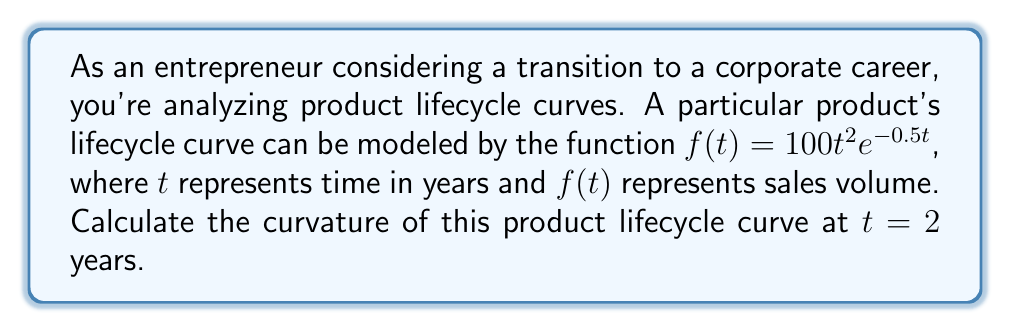Teach me how to tackle this problem. To calculate the curvature of the product lifecycle curve, we'll follow these steps:

1) The formula for curvature $\kappa$ of a function $y = f(x)$ is:

   $$\kappa = \frac{|f''(x)|}{(1 + (f'(x))^2)^{3/2}}$$

2) We need to find $f'(t)$ and $f''(t)$:

   $f(t) = 100t^2e^{-0.5t}$
   
   $f'(t) = 100(2te^{-0.5t} + t^2(-0.5)e^{-0.5t}) = 100e^{-0.5t}(2t - 0.5t^2)$
   
   $f''(t) = 100e^{-0.5t}(2 - t - 0.5(2t - 0.5t^2)) = 100e^{-0.5t}(2 - 2t + 0.25t^2)$

3) Now, we evaluate these at $t = 2$:

   $f'(2) = 100e^{-1}(4 - 2) = 200e^{-1}$
   
   $f''(2) = 100e^{-1}(2 - 4 + 1) = -100e^{-1}$

4) Substituting into the curvature formula:

   $$\kappa = \frac{|-100e^{-1}|}{(1 + (200e^{-1})^2)^{3/2}}$$

5) Simplify:

   $$\kappa = \frac{100e^{-1}}{(1 + 40000e^{-2})^{3/2}}$$

This is the curvature at $t = 2$ years.
Answer: $\kappa = \frac{100e^{-1}}{(1 + 40000e^{-2})^{3/2}}$ 